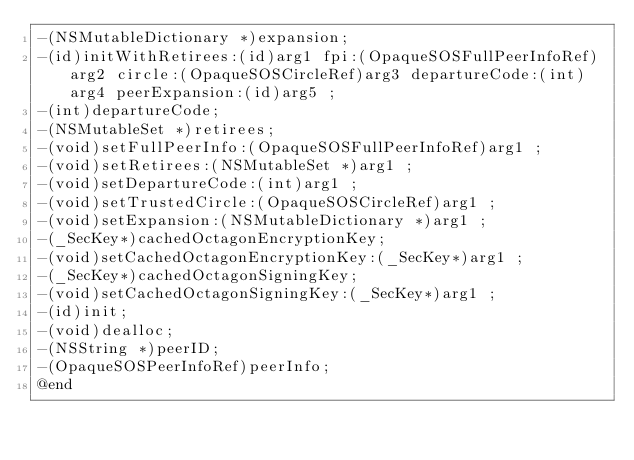Convert code to text. <code><loc_0><loc_0><loc_500><loc_500><_C_>-(NSMutableDictionary *)expansion;
-(id)initWithRetirees:(id)arg1 fpi:(OpaqueSOSFullPeerInfoRef)arg2 circle:(OpaqueSOSCircleRef)arg3 departureCode:(int)arg4 peerExpansion:(id)arg5 ;
-(int)departureCode;
-(NSMutableSet *)retirees;
-(void)setFullPeerInfo:(OpaqueSOSFullPeerInfoRef)arg1 ;
-(void)setRetirees:(NSMutableSet *)arg1 ;
-(void)setDepartureCode:(int)arg1 ;
-(void)setTrustedCircle:(OpaqueSOSCircleRef)arg1 ;
-(void)setExpansion:(NSMutableDictionary *)arg1 ;
-(_SecKey*)cachedOctagonEncryptionKey;
-(void)setCachedOctagonEncryptionKey:(_SecKey*)arg1 ;
-(_SecKey*)cachedOctagonSigningKey;
-(void)setCachedOctagonSigningKey:(_SecKey*)arg1 ;
-(id)init;
-(void)dealloc;
-(NSString *)peerID;
-(OpaqueSOSPeerInfoRef)peerInfo;
@end

</code> 